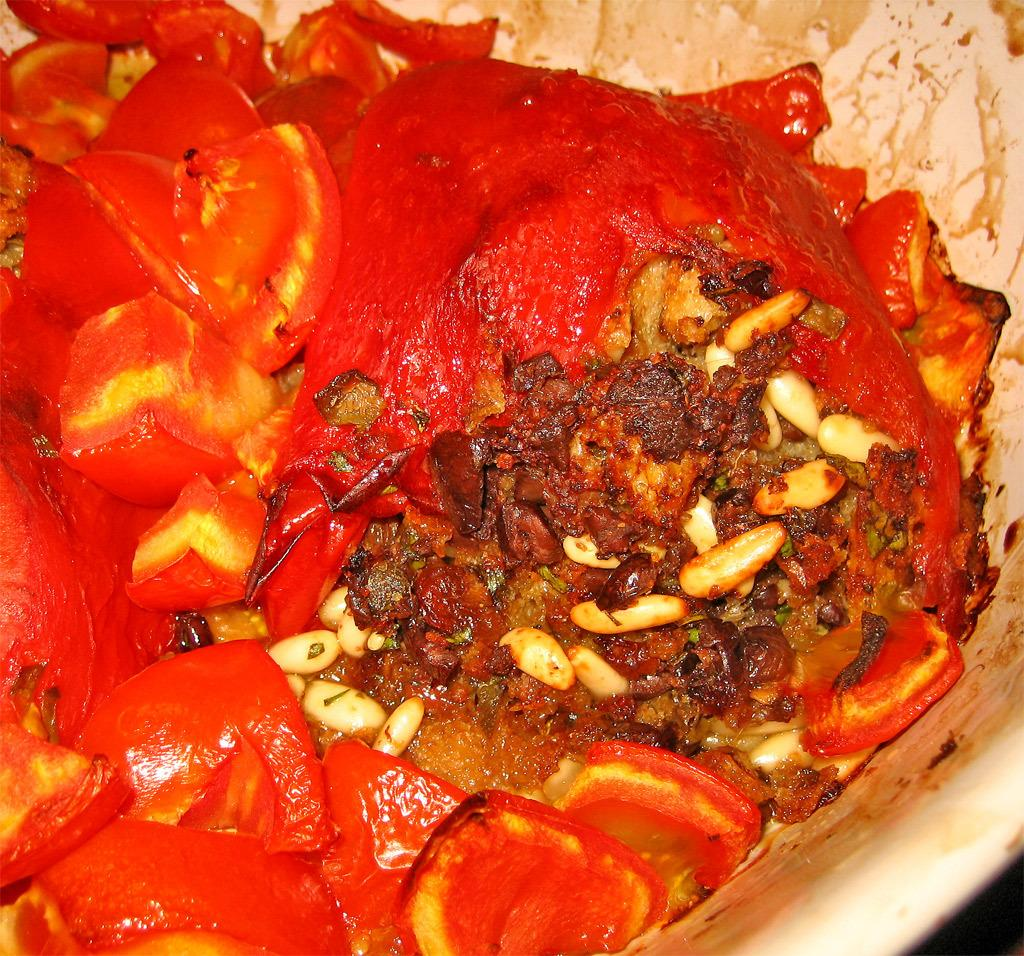What is the main subject of the image? There is a food item in the image. How is the food item presented in the image? The food item is in a white color bowl. What type of cast can be seen on the food item in the image? There is no cast present on the food item in the image. Is the food item in a crate in the image? No, the food item is in a white color bowl, not a crate. 